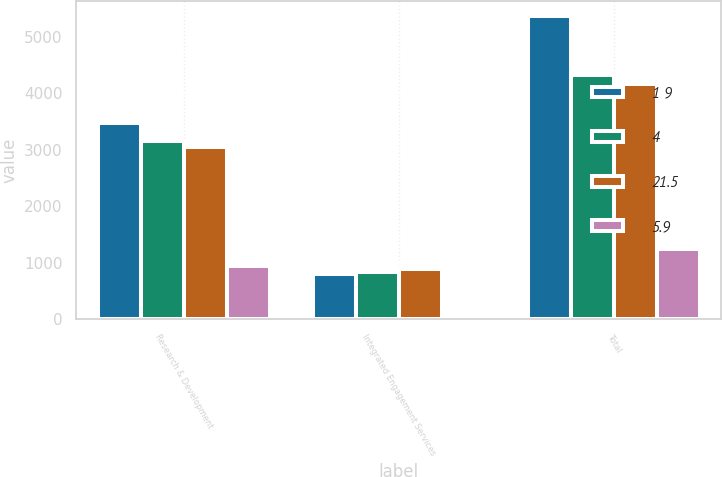Convert chart. <chart><loc_0><loc_0><loc_500><loc_500><stacked_bar_chart><ecel><fcel>Research & Development<fcel>Integrated Engagement Services<fcel>Total<nl><fcel>1 9<fcel>3472<fcel>796<fcel>5364<nl><fcel>4<fcel>3159<fcel>844<fcel>4326<nl><fcel>21.5<fcel>3050<fcel>885<fcel>4165<nl><fcel>5.9<fcel>942<fcel>75<fcel>1253<nl></chart> 